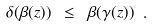<formula> <loc_0><loc_0><loc_500><loc_500>\delta ( \beta ( z ) ) \ \leq \ \beta ( \gamma ( z ) ) \ .</formula> 